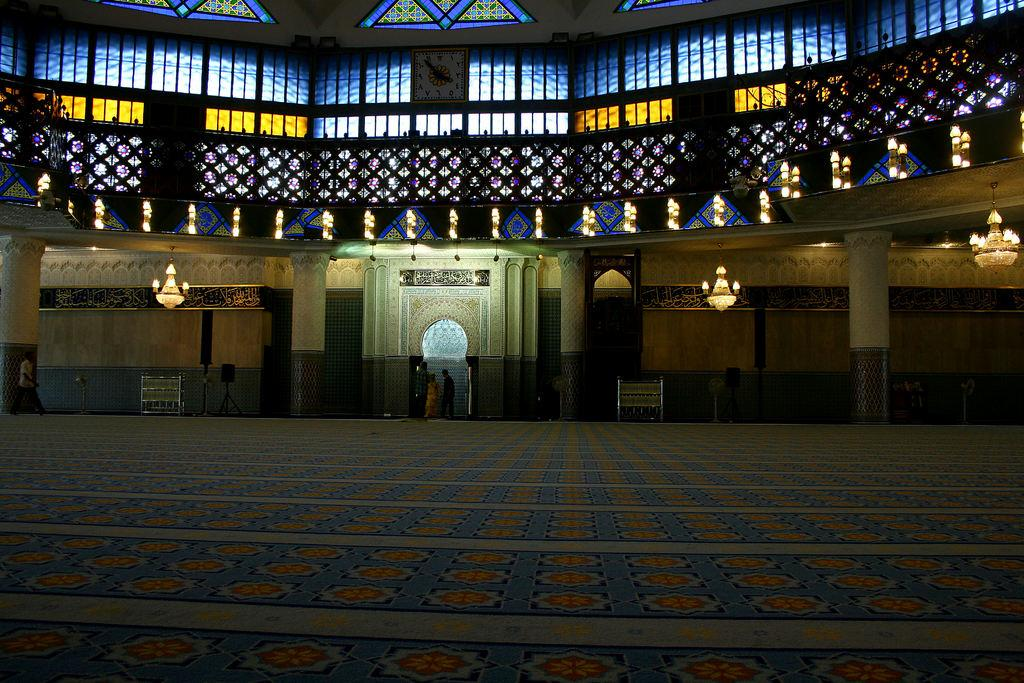Who or what can be seen in the image? There are people in the image. What type of lighting is present in the image? There are chandelier lights in the image. What devices are used for sound amplification in the image? There are speakers in the image. What type of glass is present in the image? There are stained glasses in the image. What type of structural elements can be seen in the image? There are metal rods in the image. What type of bag is being smashed by the oven in the image? There is no bag or oven present in the image. What type of oven is used to cook the food in the image? There is no oven present in the image. 